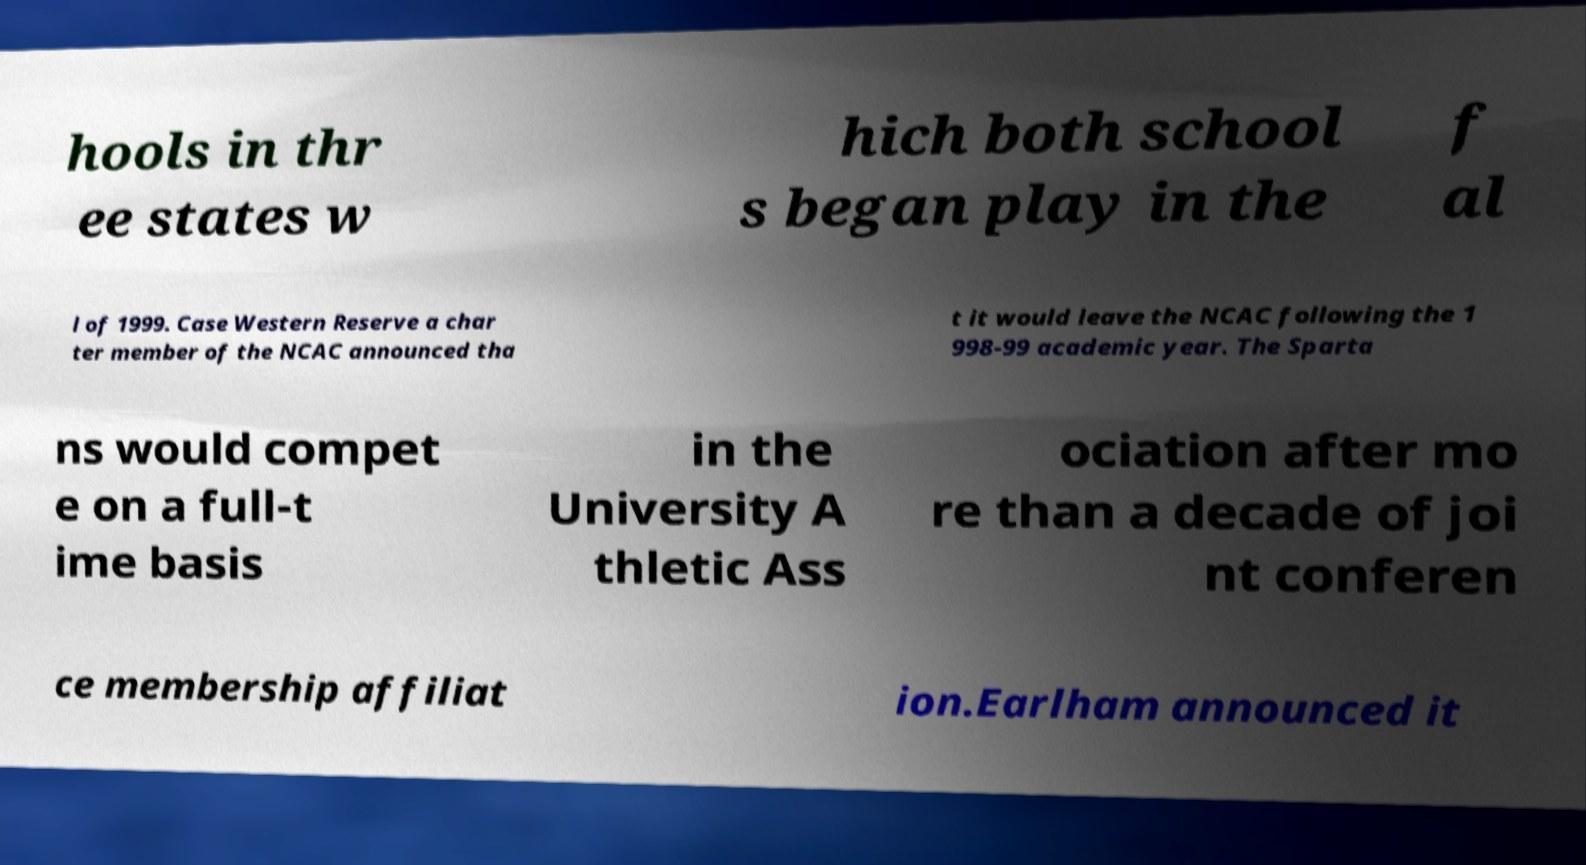Can you read and provide the text displayed in the image?This photo seems to have some interesting text. Can you extract and type it out for me? hools in thr ee states w hich both school s began play in the f al l of 1999. Case Western Reserve a char ter member of the NCAC announced tha t it would leave the NCAC following the 1 998-99 academic year. The Sparta ns would compet e on a full-t ime basis in the University A thletic Ass ociation after mo re than a decade of joi nt conferen ce membership affiliat ion.Earlham announced it 